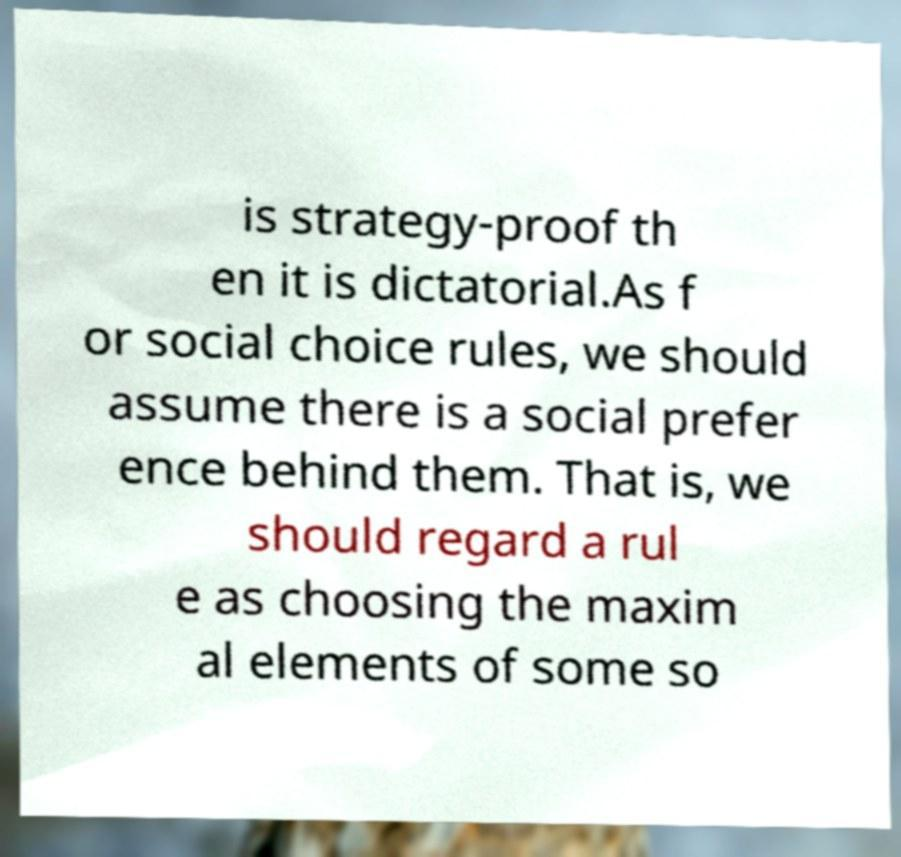For documentation purposes, I need the text within this image transcribed. Could you provide that? is strategy-proof th en it is dictatorial.As f or social choice rules, we should assume there is a social prefer ence behind them. That is, we should regard a rul e as choosing the maxim al elements of some so 